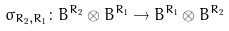Convert formula to latex. <formula><loc_0><loc_0><loc_500><loc_500>\sigma _ { R _ { 2 } , R _ { 1 } } \colon B ^ { R _ { 2 } } \otimes B ^ { R _ { 1 } } \rightarrow B ^ { R _ { 1 } } \otimes B ^ { R _ { 2 } }</formula> 